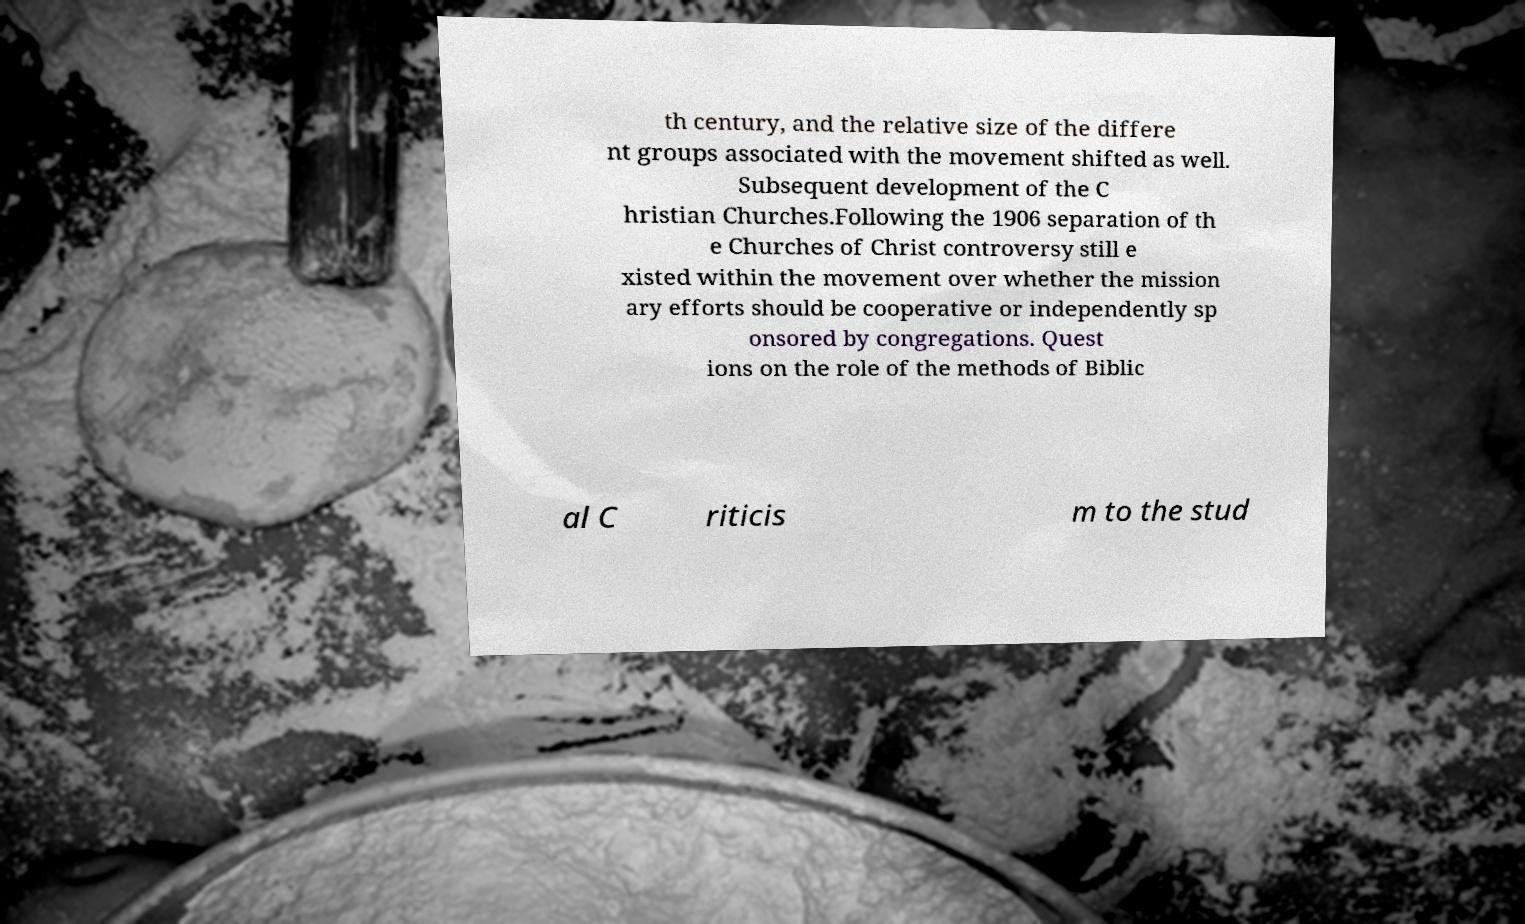Can you read and provide the text displayed in the image?This photo seems to have some interesting text. Can you extract and type it out for me? th century, and the relative size of the differe nt groups associated with the movement shifted as well. Subsequent development of the C hristian Churches.Following the 1906 separation of th e Churches of Christ controversy still e xisted within the movement over whether the mission ary efforts should be cooperative or independently sp onsored by congregations. Quest ions on the role of the methods of Biblic al C riticis m to the stud 